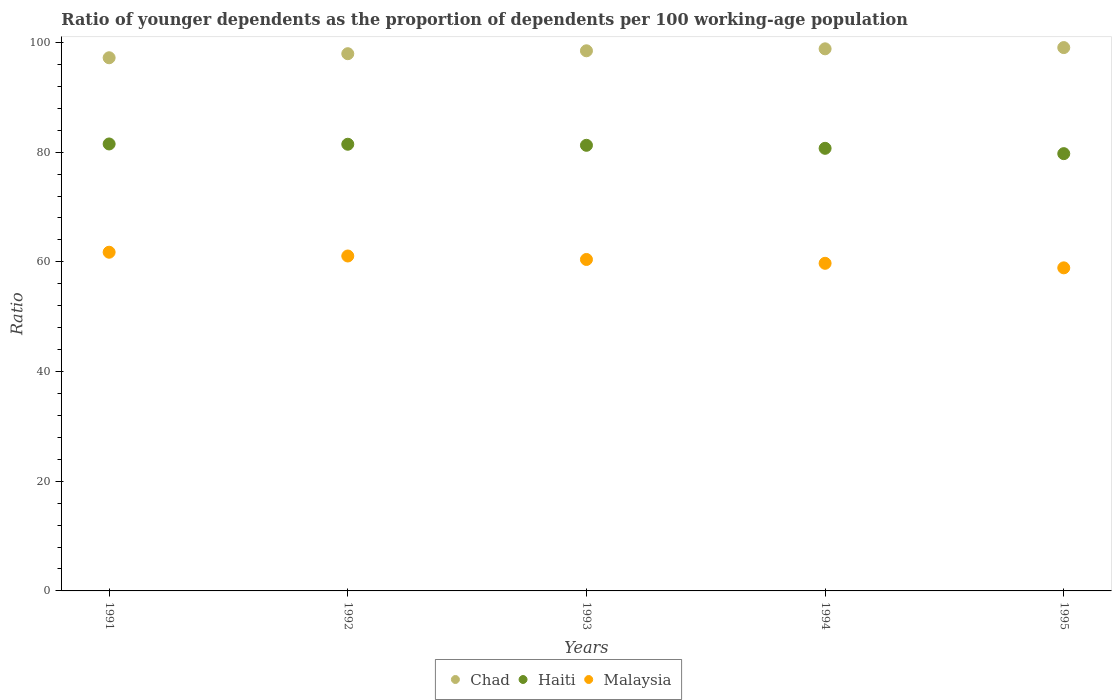How many different coloured dotlines are there?
Your response must be concise. 3. Is the number of dotlines equal to the number of legend labels?
Provide a short and direct response. Yes. What is the age dependency ratio(young) in Malaysia in 1995?
Provide a short and direct response. 58.9. Across all years, what is the maximum age dependency ratio(young) in Malaysia?
Offer a terse response. 61.75. Across all years, what is the minimum age dependency ratio(young) in Haiti?
Your answer should be compact. 79.73. In which year was the age dependency ratio(young) in Haiti minimum?
Offer a terse response. 1995. What is the total age dependency ratio(young) in Malaysia in the graph?
Your answer should be very brief. 301.88. What is the difference between the age dependency ratio(young) in Chad in 1991 and that in 1994?
Your answer should be very brief. -1.63. What is the difference between the age dependency ratio(young) in Chad in 1991 and the age dependency ratio(young) in Haiti in 1994?
Your response must be concise. 16.51. What is the average age dependency ratio(young) in Haiti per year?
Give a very brief answer. 80.92. In the year 1994, what is the difference between the age dependency ratio(young) in Haiti and age dependency ratio(young) in Malaysia?
Keep it short and to the point. 20.97. In how many years, is the age dependency ratio(young) in Malaysia greater than 68?
Your answer should be compact. 0. What is the ratio of the age dependency ratio(young) in Chad in 1992 to that in 1995?
Offer a terse response. 0.99. Is the age dependency ratio(young) in Haiti in 1992 less than that in 1995?
Ensure brevity in your answer.  No. Is the difference between the age dependency ratio(young) in Haiti in 1991 and 1995 greater than the difference between the age dependency ratio(young) in Malaysia in 1991 and 1995?
Provide a succinct answer. No. What is the difference between the highest and the second highest age dependency ratio(young) in Malaysia?
Your answer should be compact. 0.69. What is the difference between the highest and the lowest age dependency ratio(young) in Malaysia?
Ensure brevity in your answer.  2.85. In how many years, is the age dependency ratio(young) in Haiti greater than the average age dependency ratio(young) in Haiti taken over all years?
Your answer should be very brief. 3. Is the sum of the age dependency ratio(young) in Chad in 1991 and 1995 greater than the maximum age dependency ratio(young) in Haiti across all years?
Make the answer very short. Yes. Is it the case that in every year, the sum of the age dependency ratio(young) in Chad and age dependency ratio(young) in Malaysia  is greater than the age dependency ratio(young) in Haiti?
Make the answer very short. Yes. Does the age dependency ratio(young) in Malaysia monotonically increase over the years?
Keep it short and to the point. No. Is the age dependency ratio(young) in Malaysia strictly less than the age dependency ratio(young) in Chad over the years?
Your response must be concise. Yes. Where does the legend appear in the graph?
Offer a terse response. Bottom center. What is the title of the graph?
Offer a terse response. Ratio of younger dependents as the proportion of dependents per 100 working-age population. Does "Least developed countries" appear as one of the legend labels in the graph?
Provide a succinct answer. No. What is the label or title of the X-axis?
Ensure brevity in your answer.  Years. What is the label or title of the Y-axis?
Your response must be concise. Ratio. What is the Ratio of Chad in 1991?
Provide a succinct answer. 97.21. What is the Ratio in Haiti in 1991?
Offer a terse response. 81.49. What is the Ratio in Malaysia in 1991?
Offer a terse response. 61.75. What is the Ratio in Chad in 1992?
Provide a succinct answer. 97.95. What is the Ratio of Haiti in 1992?
Offer a very short reply. 81.44. What is the Ratio of Malaysia in 1992?
Provide a short and direct response. 61.07. What is the Ratio in Chad in 1993?
Offer a very short reply. 98.48. What is the Ratio of Haiti in 1993?
Keep it short and to the point. 81.25. What is the Ratio of Malaysia in 1993?
Your answer should be very brief. 60.43. What is the Ratio of Chad in 1994?
Make the answer very short. 98.84. What is the Ratio in Haiti in 1994?
Provide a short and direct response. 80.7. What is the Ratio in Malaysia in 1994?
Give a very brief answer. 59.73. What is the Ratio of Chad in 1995?
Your answer should be compact. 99.06. What is the Ratio in Haiti in 1995?
Your response must be concise. 79.73. What is the Ratio of Malaysia in 1995?
Ensure brevity in your answer.  58.9. Across all years, what is the maximum Ratio of Chad?
Your response must be concise. 99.06. Across all years, what is the maximum Ratio of Haiti?
Your answer should be compact. 81.49. Across all years, what is the maximum Ratio in Malaysia?
Your response must be concise. 61.75. Across all years, what is the minimum Ratio in Chad?
Your answer should be compact. 97.21. Across all years, what is the minimum Ratio in Haiti?
Your response must be concise. 79.73. Across all years, what is the minimum Ratio in Malaysia?
Keep it short and to the point. 58.9. What is the total Ratio in Chad in the graph?
Provide a short and direct response. 491.54. What is the total Ratio of Haiti in the graph?
Ensure brevity in your answer.  404.6. What is the total Ratio of Malaysia in the graph?
Keep it short and to the point. 301.88. What is the difference between the Ratio of Chad in 1991 and that in 1992?
Your answer should be very brief. -0.74. What is the difference between the Ratio of Haiti in 1991 and that in 1992?
Ensure brevity in your answer.  0.05. What is the difference between the Ratio in Malaysia in 1991 and that in 1992?
Offer a terse response. 0.69. What is the difference between the Ratio of Chad in 1991 and that in 1993?
Give a very brief answer. -1.27. What is the difference between the Ratio of Haiti in 1991 and that in 1993?
Offer a very short reply. 0.24. What is the difference between the Ratio of Malaysia in 1991 and that in 1993?
Keep it short and to the point. 1.32. What is the difference between the Ratio of Chad in 1991 and that in 1994?
Offer a terse response. -1.63. What is the difference between the Ratio of Haiti in 1991 and that in 1994?
Provide a short and direct response. 0.79. What is the difference between the Ratio in Malaysia in 1991 and that in 1994?
Make the answer very short. 2.02. What is the difference between the Ratio in Chad in 1991 and that in 1995?
Offer a terse response. -1.85. What is the difference between the Ratio of Haiti in 1991 and that in 1995?
Your response must be concise. 1.76. What is the difference between the Ratio in Malaysia in 1991 and that in 1995?
Ensure brevity in your answer.  2.85. What is the difference between the Ratio of Chad in 1992 and that in 1993?
Keep it short and to the point. -0.53. What is the difference between the Ratio in Haiti in 1992 and that in 1993?
Your response must be concise. 0.19. What is the difference between the Ratio of Malaysia in 1992 and that in 1993?
Offer a terse response. 0.63. What is the difference between the Ratio of Chad in 1992 and that in 1994?
Keep it short and to the point. -0.89. What is the difference between the Ratio in Haiti in 1992 and that in 1994?
Your answer should be compact. 0.74. What is the difference between the Ratio in Malaysia in 1992 and that in 1994?
Your answer should be very brief. 1.33. What is the difference between the Ratio in Chad in 1992 and that in 1995?
Your answer should be very brief. -1.11. What is the difference between the Ratio in Haiti in 1992 and that in 1995?
Your answer should be very brief. 1.71. What is the difference between the Ratio of Malaysia in 1992 and that in 1995?
Your response must be concise. 2.16. What is the difference between the Ratio in Chad in 1993 and that in 1994?
Provide a succinct answer. -0.36. What is the difference between the Ratio in Haiti in 1993 and that in 1994?
Make the answer very short. 0.55. What is the difference between the Ratio of Malaysia in 1993 and that in 1994?
Provide a short and direct response. 0.7. What is the difference between the Ratio in Chad in 1993 and that in 1995?
Give a very brief answer. -0.58. What is the difference between the Ratio of Haiti in 1993 and that in 1995?
Keep it short and to the point. 1.52. What is the difference between the Ratio in Malaysia in 1993 and that in 1995?
Make the answer very short. 1.53. What is the difference between the Ratio in Chad in 1994 and that in 1995?
Give a very brief answer. -0.23. What is the difference between the Ratio in Haiti in 1994 and that in 1995?
Ensure brevity in your answer.  0.97. What is the difference between the Ratio of Malaysia in 1994 and that in 1995?
Offer a very short reply. 0.83. What is the difference between the Ratio of Chad in 1991 and the Ratio of Haiti in 1992?
Your response must be concise. 15.77. What is the difference between the Ratio of Chad in 1991 and the Ratio of Malaysia in 1992?
Your response must be concise. 36.14. What is the difference between the Ratio in Haiti in 1991 and the Ratio in Malaysia in 1992?
Keep it short and to the point. 20.43. What is the difference between the Ratio of Chad in 1991 and the Ratio of Haiti in 1993?
Provide a short and direct response. 15.96. What is the difference between the Ratio of Chad in 1991 and the Ratio of Malaysia in 1993?
Make the answer very short. 36.78. What is the difference between the Ratio of Haiti in 1991 and the Ratio of Malaysia in 1993?
Offer a very short reply. 21.06. What is the difference between the Ratio of Chad in 1991 and the Ratio of Haiti in 1994?
Make the answer very short. 16.51. What is the difference between the Ratio in Chad in 1991 and the Ratio in Malaysia in 1994?
Keep it short and to the point. 37.48. What is the difference between the Ratio of Haiti in 1991 and the Ratio of Malaysia in 1994?
Give a very brief answer. 21.76. What is the difference between the Ratio of Chad in 1991 and the Ratio of Haiti in 1995?
Provide a succinct answer. 17.48. What is the difference between the Ratio of Chad in 1991 and the Ratio of Malaysia in 1995?
Your answer should be compact. 38.3. What is the difference between the Ratio in Haiti in 1991 and the Ratio in Malaysia in 1995?
Offer a terse response. 22.59. What is the difference between the Ratio in Chad in 1992 and the Ratio in Haiti in 1993?
Your response must be concise. 16.7. What is the difference between the Ratio of Chad in 1992 and the Ratio of Malaysia in 1993?
Keep it short and to the point. 37.52. What is the difference between the Ratio in Haiti in 1992 and the Ratio in Malaysia in 1993?
Ensure brevity in your answer.  21.01. What is the difference between the Ratio in Chad in 1992 and the Ratio in Haiti in 1994?
Provide a short and direct response. 17.25. What is the difference between the Ratio in Chad in 1992 and the Ratio in Malaysia in 1994?
Provide a succinct answer. 38.22. What is the difference between the Ratio in Haiti in 1992 and the Ratio in Malaysia in 1994?
Offer a terse response. 21.71. What is the difference between the Ratio in Chad in 1992 and the Ratio in Haiti in 1995?
Ensure brevity in your answer.  18.22. What is the difference between the Ratio in Chad in 1992 and the Ratio in Malaysia in 1995?
Give a very brief answer. 39.04. What is the difference between the Ratio of Haiti in 1992 and the Ratio of Malaysia in 1995?
Ensure brevity in your answer.  22.53. What is the difference between the Ratio of Chad in 1993 and the Ratio of Haiti in 1994?
Your answer should be very brief. 17.78. What is the difference between the Ratio in Chad in 1993 and the Ratio in Malaysia in 1994?
Offer a terse response. 38.75. What is the difference between the Ratio in Haiti in 1993 and the Ratio in Malaysia in 1994?
Offer a terse response. 21.52. What is the difference between the Ratio in Chad in 1993 and the Ratio in Haiti in 1995?
Your answer should be very brief. 18.75. What is the difference between the Ratio in Chad in 1993 and the Ratio in Malaysia in 1995?
Your answer should be compact. 39.57. What is the difference between the Ratio of Haiti in 1993 and the Ratio of Malaysia in 1995?
Offer a terse response. 22.34. What is the difference between the Ratio in Chad in 1994 and the Ratio in Haiti in 1995?
Your response must be concise. 19.11. What is the difference between the Ratio of Chad in 1994 and the Ratio of Malaysia in 1995?
Your answer should be very brief. 39.93. What is the difference between the Ratio in Haiti in 1994 and the Ratio in Malaysia in 1995?
Give a very brief answer. 21.79. What is the average Ratio of Chad per year?
Provide a short and direct response. 98.31. What is the average Ratio in Haiti per year?
Your answer should be compact. 80.92. What is the average Ratio in Malaysia per year?
Make the answer very short. 60.38. In the year 1991, what is the difference between the Ratio in Chad and Ratio in Haiti?
Provide a short and direct response. 15.72. In the year 1991, what is the difference between the Ratio of Chad and Ratio of Malaysia?
Ensure brevity in your answer.  35.46. In the year 1991, what is the difference between the Ratio in Haiti and Ratio in Malaysia?
Keep it short and to the point. 19.74. In the year 1992, what is the difference between the Ratio of Chad and Ratio of Haiti?
Make the answer very short. 16.51. In the year 1992, what is the difference between the Ratio of Chad and Ratio of Malaysia?
Give a very brief answer. 36.88. In the year 1992, what is the difference between the Ratio of Haiti and Ratio of Malaysia?
Your answer should be compact. 20.37. In the year 1993, what is the difference between the Ratio in Chad and Ratio in Haiti?
Your answer should be compact. 17.23. In the year 1993, what is the difference between the Ratio of Chad and Ratio of Malaysia?
Your response must be concise. 38.05. In the year 1993, what is the difference between the Ratio of Haiti and Ratio of Malaysia?
Keep it short and to the point. 20.82. In the year 1994, what is the difference between the Ratio of Chad and Ratio of Haiti?
Ensure brevity in your answer.  18.14. In the year 1994, what is the difference between the Ratio of Chad and Ratio of Malaysia?
Your answer should be very brief. 39.11. In the year 1994, what is the difference between the Ratio of Haiti and Ratio of Malaysia?
Your response must be concise. 20.97. In the year 1995, what is the difference between the Ratio in Chad and Ratio in Haiti?
Ensure brevity in your answer.  19.34. In the year 1995, what is the difference between the Ratio in Chad and Ratio in Malaysia?
Make the answer very short. 40.16. In the year 1995, what is the difference between the Ratio of Haiti and Ratio of Malaysia?
Offer a terse response. 20.82. What is the ratio of the Ratio of Chad in 1991 to that in 1992?
Provide a short and direct response. 0.99. What is the ratio of the Ratio in Haiti in 1991 to that in 1992?
Keep it short and to the point. 1. What is the ratio of the Ratio in Malaysia in 1991 to that in 1992?
Your answer should be compact. 1.01. What is the ratio of the Ratio in Chad in 1991 to that in 1993?
Make the answer very short. 0.99. What is the ratio of the Ratio in Malaysia in 1991 to that in 1993?
Provide a short and direct response. 1.02. What is the ratio of the Ratio in Chad in 1991 to that in 1994?
Your answer should be very brief. 0.98. What is the ratio of the Ratio of Haiti in 1991 to that in 1994?
Offer a terse response. 1.01. What is the ratio of the Ratio in Malaysia in 1991 to that in 1994?
Make the answer very short. 1.03. What is the ratio of the Ratio in Chad in 1991 to that in 1995?
Provide a short and direct response. 0.98. What is the ratio of the Ratio in Haiti in 1991 to that in 1995?
Provide a short and direct response. 1.02. What is the ratio of the Ratio of Malaysia in 1991 to that in 1995?
Ensure brevity in your answer.  1.05. What is the ratio of the Ratio in Malaysia in 1992 to that in 1993?
Your response must be concise. 1.01. What is the ratio of the Ratio of Chad in 1992 to that in 1994?
Provide a short and direct response. 0.99. What is the ratio of the Ratio of Haiti in 1992 to that in 1994?
Ensure brevity in your answer.  1.01. What is the ratio of the Ratio of Malaysia in 1992 to that in 1994?
Your answer should be compact. 1.02. What is the ratio of the Ratio in Chad in 1992 to that in 1995?
Offer a very short reply. 0.99. What is the ratio of the Ratio in Haiti in 1992 to that in 1995?
Your response must be concise. 1.02. What is the ratio of the Ratio in Malaysia in 1992 to that in 1995?
Keep it short and to the point. 1.04. What is the ratio of the Ratio of Chad in 1993 to that in 1994?
Make the answer very short. 1. What is the ratio of the Ratio in Haiti in 1993 to that in 1994?
Your answer should be very brief. 1.01. What is the ratio of the Ratio of Malaysia in 1993 to that in 1994?
Keep it short and to the point. 1.01. What is the ratio of the Ratio of Chad in 1993 to that in 1995?
Give a very brief answer. 0.99. What is the ratio of the Ratio of Haiti in 1993 to that in 1995?
Your answer should be very brief. 1.02. What is the ratio of the Ratio of Malaysia in 1993 to that in 1995?
Your answer should be very brief. 1.03. What is the ratio of the Ratio in Haiti in 1994 to that in 1995?
Give a very brief answer. 1.01. What is the ratio of the Ratio of Malaysia in 1994 to that in 1995?
Provide a succinct answer. 1.01. What is the difference between the highest and the second highest Ratio of Chad?
Your answer should be very brief. 0.23. What is the difference between the highest and the second highest Ratio in Haiti?
Keep it short and to the point. 0.05. What is the difference between the highest and the second highest Ratio in Malaysia?
Offer a very short reply. 0.69. What is the difference between the highest and the lowest Ratio of Chad?
Provide a short and direct response. 1.85. What is the difference between the highest and the lowest Ratio in Haiti?
Give a very brief answer. 1.76. What is the difference between the highest and the lowest Ratio of Malaysia?
Offer a very short reply. 2.85. 